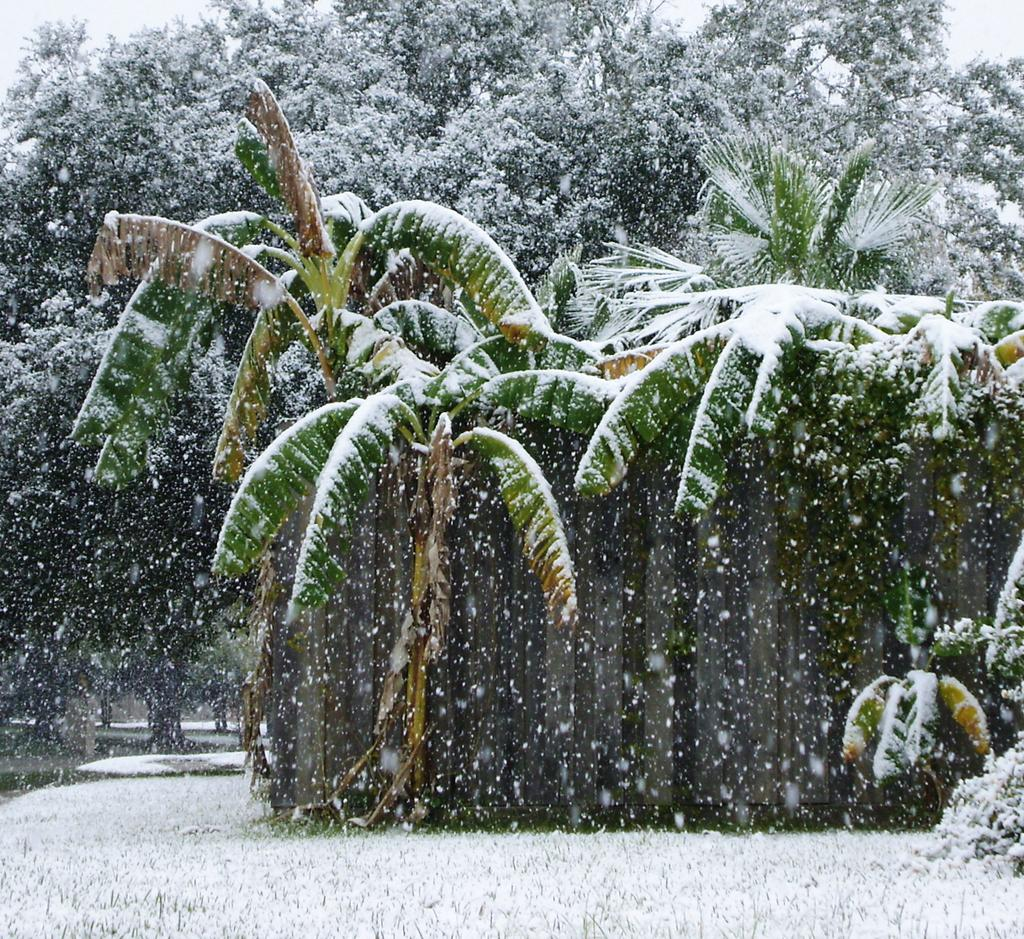What type of vegetation can be seen in the image? There are trees in the image. What is covering the ground in the image? There is snow on the ground in the image. Are the trees also covered in the same substance as the ground? Yes, there is snow on the trees in the image. What can be seen at the top of the image? The sky is visible at the top of the image. Can you see any feathers falling from the sky in the image? There are no feathers visible in the image; it primarily features trees, snow, and sky. Is there a bell ringing in the image? There is no bell present or mentioned in the image. 